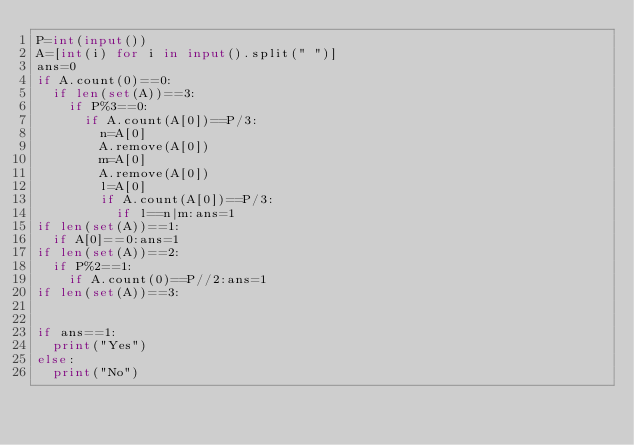Convert code to text. <code><loc_0><loc_0><loc_500><loc_500><_Python_>P=int(input())
A=[int(i) for i in input().split(" ")]
ans=0
if A.count(0)==0:
	if len(set(A))==3:
		if P%3==0:
			if A.count(A[0])==P/3:
				n=A[0]
				A.remove(A[0])
				m=A[0]
				A.remove(A[0])
				l=A[0]
				if A.count(A[0])==P/3:
					if l==n|m:ans=1
if len(set(A))==1:
	if A[0]==0:ans=1
if len(set(A))==2:
	if P%2==1:
		if A.count(0)==P//2:ans=1
if len(set(A))==3:


if ans==1:
	print("Yes")
else:
	print("No")
</code> 